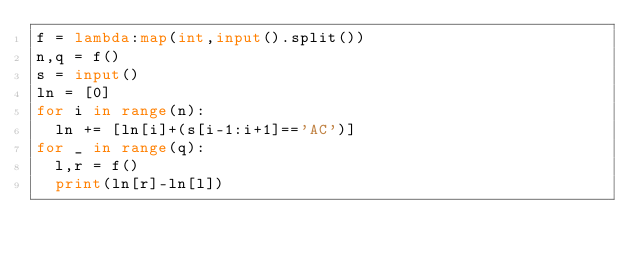Convert code to text. <code><loc_0><loc_0><loc_500><loc_500><_Python_>f = lambda:map(int,input().split())
n,q = f()
s = input()
ln = [0]
for i in range(n):
  ln += [ln[i]+(s[i-1:i+1]=='AC')]
for _ in range(q):
  l,r = f()
  print(ln[r]-ln[l])</code> 